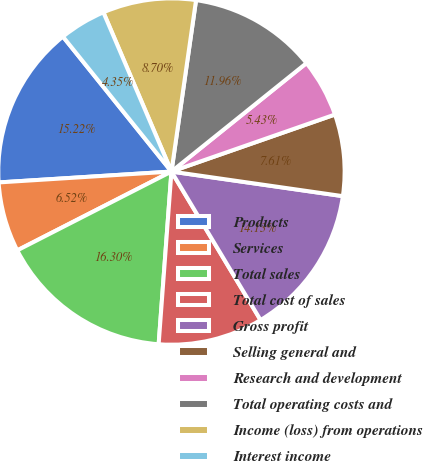Convert chart. <chart><loc_0><loc_0><loc_500><loc_500><pie_chart><fcel>Products<fcel>Services<fcel>Total sales<fcel>Total cost of sales<fcel>Gross profit<fcel>Selling general and<fcel>Research and development<fcel>Total operating costs and<fcel>Income (loss) from operations<fcel>Interest income<nl><fcel>15.22%<fcel>6.52%<fcel>16.3%<fcel>9.78%<fcel>14.13%<fcel>7.61%<fcel>5.43%<fcel>11.96%<fcel>8.7%<fcel>4.35%<nl></chart> 